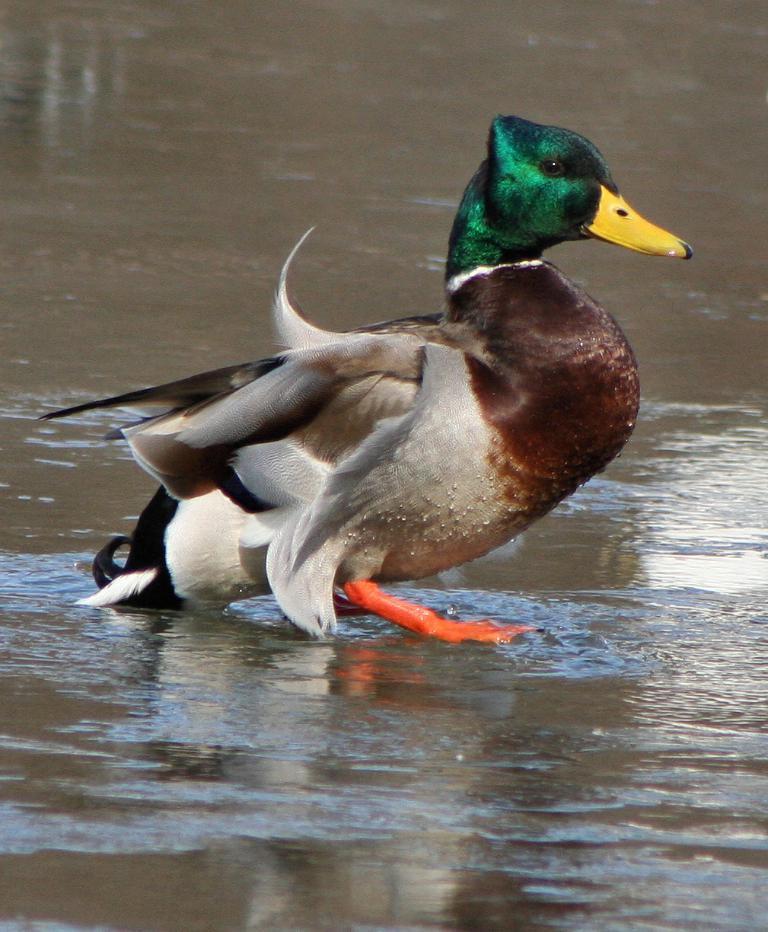How would you summarize this image in a sentence or two? In this image we can see a duck in the water. 